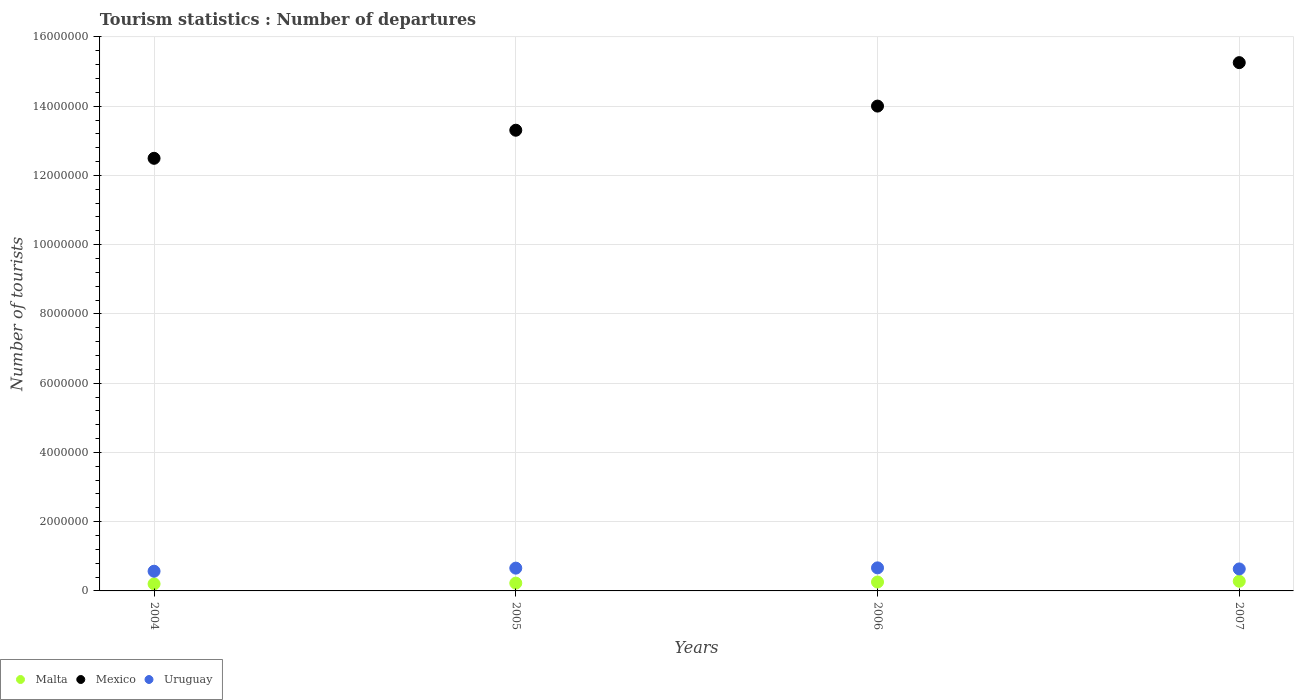How many different coloured dotlines are there?
Provide a succinct answer. 3. Is the number of dotlines equal to the number of legend labels?
Give a very brief answer. Yes. What is the number of tourist departures in Uruguay in 2005?
Provide a short and direct response. 6.58e+05. Across all years, what is the maximum number of tourist departures in Uruguay?
Your response must be concise. 6.66e+05. Across all years, what is the minimum number of tourist departures in Malta?
Make the answer very short. 2.03e+05. In which year was the number of tourist departures in Uruguay minimum?
Offer a very short reply. 2004. What is the total number of tourist departures in Malta in the graph?
Ensure brevity in your answer.  9.65e+05. What is the difference between the number of tourist departures in Uruguay in 2004 and that in 2006?
Provide a short and direct response. -9.70e+04. What is the difference between the number of tourist departures in Malta in 2005 and the number of tourist departures in Mexico in 2007?
Your answer should be very brief. -1.50e+07. What is the average number of tourist departures in Malta per year?
Keep it short and to the point. 2.41e+05. In the year 2004, what is the difference between the number of tourist departures in Uruguay and number of tourist departures in Mexico?
Keep it short and to the point. -1.19e+07. What is the ratio of the number of tourist departures in Malta in 2005 to that in 2006?
Provide a succinct answer. 0.88. Is the number of tourist departures in Uruguay in 2004 less than that in 2007?
Provide a succinct answer. Yes. What is the difference between the highest and the second highest number of tourist departures in Mexico?
Your response must be concise. 1.26e+06. What is the difference between the highest and the lowest number of tourist departures in Mexico?
Your answer should be compact. 2.76e+06. Is it the case that in every year, the sum of the number of tourist departures in Mexico and number of tourist departures in Uruguay  is greater than the number of tourist departures in Malta?
Keep it short and to the point. Yes. Does the number of tourist departures in Uruguay monotonically increase over the years?
Ensure brevity in your answer.  No. Is the number of tourist departures in Mexico strictly greater than the number of tourist departures in Malta over the years?
Offer a very short reply. Yes. How many dotlines are there?
Ensure brevity in your answer.  3. How many years are there in the graph?
Offer a very short reply. 4. What is the difference between two consecutive major ticks on the Y-axis?
Offer a very short reply. 2.00e+06. Are the values on the major ticks of Y-axis written in scientific E-notation?
Offer a very short reply. No. Does the graph contain any zero values?
Offer a terse response. No. Where does the legend appear in the graph?
Ensure brevity in your answer.  Bottom left. How many legend labels are there?
Give a very brief answer. 3. How are the legend labels stacked?
Offer a very short reply. Horizontal. What is the title of the graph?
Provide a short and direct response. Tourism statistics : Number of departures. What is the label or title of the Y-axis?
Provide a short and direct response. Number of tourists. What is the Number of tourists in Malta in 2004?
Ensure brevity in your answer.  2.03e+05. What is the Number of tourists of Mexico in 2004?
Your answer should be very brief. 1.25e+07. What is the Number of tourists of Uruguay in 2004?
Offer a very short reply. 5.69e+05. What is the Number of tourists in Malta in 2005?
Offer a terse response. 2.25e+05. What is the Number of tourists of Mexico in 2005?
Give a very brief answer. 1.33e+07. What is the Number of tourists in Uruguay in 2005?
Make the answer very short. 6.58e+05. What is the Number of tourists in Malta in 2006?
Offer a very short reply. 2.57e+05. What is the Number of tourists of Mexico in 2006?
Provide a short and direct response. 1.40e+07. What is the Number of tourists of Uruguay in 2006?
Your answer should be very brief. 6.66e+05. What is the Number of tourists in Mexico in 2007?
Make the answer very short. 1.53e+07. What is the Number of tourists of Uruguay in 2007?
Provide a succinct answer. 6.35e+05. Across all years, what is the maximum Number of tourists of Malta?
Give a very brief answer. 2.80e+05. Across all years, what is the maximum Number of tourists of Mexico?
Provide a succinct answer. 1.53e+07. Across all years, what is the maximum Number of tourists of Uruguay?
Provide a short and direct response. 6.66e+05. Across all years, what is the minimum Number of tourists in Malta?
Your response must be concise. 2.03e+05. Across all years, what is the minimum Number of tourists in Mexico?
Provide a succinct answer. 1.25e+07. Across all years, what is the minimum Number of tourists of Uruguay?
Keep it short and to the point. 5.69e+05. What is the total Number of tourists of Malta in the graph?
Your answer should be very brief. 9.65e+05. What is the total Number of tourists of Mexico in the graph?
Offer a terse response. 5.51e+07. What is the total Number of tourists in Uruguay in the graph?
Ensure brevity in your answer.  2.53e+06. What is the difference between the Number of tourists of Malta in 2004 and that in 2005?
Keep it short and to the point. -2.20e+04. What is the difference between the Number of tourists of Mexico in 2004 and that in 2005?
Give a very brief answer. -8.11e+05. What is the difference between the Number of tourists of Uruguay in 2004 and that in 2005?
Make the answer very short. -8.90e+04. What is the difference between the Number of tourists of Malta in 2004 and that in 2006?
Make the answer very short. -5.40e+04. What is the difference between the Number of tourists in Mexico in 2004 and that in 2006?
Ensure brevity in your answer.  -1.51e+06. What is the difference between the Number of tourists of Uruguay in 2004 and that in 2006?
Your answer should be very brief. -9.70e+04. What is the difference between the Number of tourists in Malta in 2004 and that in 2007?
Offer a very short reply. -7.70e+04. What is the difference between the Number of tourists of Mexico in 2004 and that in 2007?
Keep it short and to the point. -2.76e+06. What is the difference between the Number of tourists in Uruguay in 2004 and that in 2007?
Your answer should be compact. -6.60e+04. What is the difference between the Number of tourists of Malta in 2005 and that in 2006?
Make the answer very short. -3.20e+04. What is the difference between the Number of tourists in Mexico in 2005 and that in 2006?
Your response must be concise. -6.97e+05. What is the difference between the Number of tourists of Uruguay in 2005 and that in 2006?
Your answer should be very brief. -8000. What is the difference between the Number of tourists of Malta in 2005 and that in 2007?
Provide a succinct answer. -5.50e+04. What is the difference between the Number of tourists in Mexico in 2005 and that in 2007?
Offer a very short reply. -1.95e+06. What is the difference between the Number of tourists in Uruguay in 2005 and that in 2007?
Keep it short and to the point. 2.30e+04. What is the difference between the Number of tourists in Malta in 2006 and that in 2007?
Provide a succinct answer. -2.30e+04. What is the difference between the Number of tourists of Mexico in 2006 and that in 2007?
Provide a succinct answer. -1.26e+06. What is the difference between the Number of tourists of Uruguay in 2006 and that in 2007?
Your answer should be compact. 3.10e+04. What is the difference between the Number of tourists of Malta in 2004 and the Number of tourists of Mexico in 2005?
Offer a terse response. -1.31e+07. What is the difference between the Number of tourists in Malta in 2004 and the Number of tourists in Uruguay in 2005?
Your answer should be very brief. -4.55e+05. What is the difference between the Number of tourists in Mexico in 2004 and the Number of tourists in Uruguay in 2005?
Offer a very short reply. 1.18e+07. What is the difference between the Number of tourists of Malta in 2004 and the Number of tourists of Mexico in 2006?
Provide a short and direct response. -1.38e+07. What is the difference between the Number of tourists in Malta in 2004 and the Number of tourists in Uruguay in 2006?
Provide a succinct answer. -4.63e+05. What is the difference between the Number of tourists of Mexico in 2004 and the Number of tourists of Uruguay in 2006?
Offer a terse response. 1.18e+07. What is the difference between the Number of tourists of Malta in 2004 and the Number of tourists of Mexico in 2007?
Offer a very short reply. -1.51e+07. What is the difference between the Number of tourists in Malta in 2004 and the Number of tourists in Uruguay in 2007?
Provide a short and direct response. -4.32e+05. What is the difference between the Number of tourists in Mexico in 2004 and the Number of tourists in Uruguay in 2007?
Give a very brief answer. 1.19e+07. What is the difference between the Number of tourists of Malta in 2005 and the Number of tourists of Mexico in 2006?
Offer a terse response. -1.38e+07. What is the difference between the Number of tourists in Malta in 2005 and the Number of tourists in Uruguay in 2006?
Ensure brevity in your answer.  -4.41e+05. What is the difference between the Number of tourists of Mexico in 2005 and the Number of tourists of Uruguay in 2006?
Provide a short and direct response. 1.26e+07. What is the difference between the Number of tourists in Malta in 2005 and the Number of tourists in Mexico in 2007?
Your answer should be compact. -1.50e+07. What is the difference between the Number of tourists of Malta in 2005 and the Number of tourists of Uruguay in 2007?
Offer a terse response. -4.10e+05. What is the difference between the Number of tourists in Mexico in 2005 and the Number of tourists in Uruguay in 2007?
Your answer should be very brief. 1.27e+07. What is the difference between the Number of tourists in Malta in 2006 and the Number of tourists in Mexico in 2007?
Your answer should be compact. -1.50e+07. What is the difference between the Number of tourists of Malta in 2006 and the Number of tourists of Uruguay in 2007?
Your answer should be compact. -3.78e+05. What is the difference between the Number of tourists in Mexico in 2006 and the Number of tourists in Uruguay in 2007?
Ensure brevity in your answer.  1.34e+07. What is the average Number of tourists in Malta per year?
Offer a terse response. 2.41e+05. What is the average Number of tourists in Mexico per year?
Offer a terse response. 1.38e+07. What is the average Number of tourists of Uruguay per year?
Make the answer very short. 6.32e+05. In the year 2004, what is the difference between the Number of tourists in Malta and Number of tourists in Mexico?
Give a very brief answer. -1.23e+07. In the year 2004, what is the difference between the Number of tourists in Malta and Number of tourists in Uruguay?
Keep it short and to the point. -3.66e+05. In the year 2004, what is the difference between the Number of tourists of Mexico and Number of tourists of Uruguay?
Your answer should be very brief. 1.19e+07. In the year 2005, what is the difference between the Number of tourists of Malta and Number of tourists of Mexico?
Provide a short and direct response. -1.31e+07. In the year 2005, what is the difference between the Number of tourists in Malta and Number of tourists in Uruguay?
Your response must be concise. -4.33e+05. In the year 2005, what is the difference between the Number of tourists of Mexico and Number of tourists of Uruguay?
Make the answer very short. 1.26e+07. In the year 2006, what is the difference between the Number of tourists in Malta and Number of tourists in Mexico?
Ensure brevity in your answer.  -1.37e+07. In the year 2006, what is the difference between the Number of tourists of Malta and Number of tourists of Uruguay?
Your response must be concise. -4.09e+05. In the year 2006, what is the difference between the Number of tourists in Mexico and Number of tourists in Uruguay?
Offer a terse response. 1.33e+07. In the year 2007, what is the difference between the Number of tourists in Malta and Number of tourists in Mexico?
Provide a succinct answer. -1.50e+07. In the year 2007, what is the difference between the Number of tourists of Malta and Number of tourists of Uruguay?
Offer a terse response. -3.55e+05. In the year 2007, what is the difference between the Number of tourists of Mexico and Number of tourists of Uruguay?
Your answer should be very brief. 1.46e+07. What is the ratio of the Number of tourists of Malta in 2004 to that in 2005?
Make the answer very short. 0.9. What is the ratio of the Number of tourists in Mexico in 2004 to that in 2005?
Your response must be concise. 0.94. What is the ratio of the Number of tourists in Uruguay in 2004 to that in 2005?
Provide a short and direct response. 0.86. What is the ratio of the Number of tourists of Malta in 2004 to that in 2006?
Make the answer very short. 0.79. What is the ratio of the Number of tourists in Mexico in 2004 to that in 2006?
Make the answer very short. 0.89. What is the ratio of the Number of tourists in Uruguay in 2004 to that in 2006?
Your response must be concise. 0.85. What is the ratio of the Number of tourists of Malta in 2004 to that in 2007?
Ensure brevity in your answer.  0.72. What is the ratio of the Number of tourists of Mexico in 2004 to that in 2007?
Offer a very short reply. 0.82. What is the ratio of the Number of tourists in Uruguay in 2004 to that in 2007?
Provide a short and direct response. 0.9. What is the ratio of the Number of tourists in Malta in 2005 to that in 2006?
Your answer should be compact. 0.88. What is the ratio of the Number of tourists of Mexico in 2005 to that in 2006?
Your response must be concise. 0.95. What is the ratio of the Number of tourists in Malta in 2005 to that in 2007?
Provide a succinct answer. 0.8. What is the ratio of the Number of tourists in Mexico in 2005 to that in 2007?
Offer a very short reply. 0.87. What is the ratio of the Number of tourists of Uruguay in 2005 to that in 2007?
Keep it short and to the point. 1.04. What is the ratio of the Number of tourists in Malta in 2006 to that in 2007?
Provide a succinct answer. 0.92. What is the ratio of the Number of tourists of Mexico in 2006 to that in 2007?
Your answer should be compact. 0.92. What is the ratio of the Number of tourists of Uruguay in 2006 to that in 2007?
Offer a very short reply. 1.05. What is the difference between the highest and the second highest Number of tourists of Malta?
Offer a very short reply. 2.30e+04. What is the difference between the highest and the second highest Number of tourists in Mexico?
Your answer should be very brief. 1.26e+06. What is the difference between the highest and the second highest Number of tourists of Uruguay?
Provide a succinct answer. 8000. What is the difference between the highest and the lowest Number of tourists of Malta?
Provide a succinct answer. 7.70e+04. What is the difference between the highest and the lowest Number of tourists of Mexico?
Offer a very short reply. 2.76e+06. What is the difference between the highest and the lowest Number of tourists in Uruguay?
Your answer should be compact. 9.70e+04. 